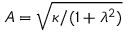<formula> <loc_0><loc_0><loc_500><loc_500>A = \sqrt { \kappa / ( 1 + { \lambda } ^ { 2 } ) }</formula> 